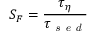<formula> <loc_0><loc_0><loc_500><loc_500>S _ { F } = \frac { \tau _ { \eta } } { \tau _ { s e d } }</formula> 